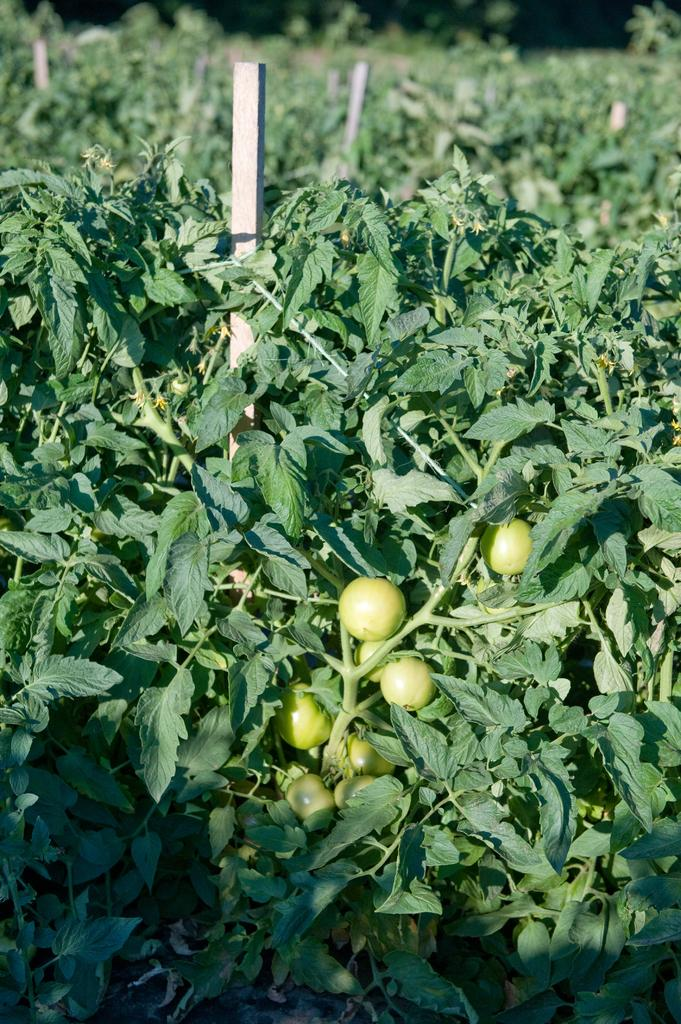What type of living organisms can be seen in the image? There are many plants in the image. What else can be seen in the image besides plants? There are fruits in the image. Can you describe any other objects in the image? There are unspecified objects in the image. What type of tramp can be seen in the image? There is no tramp present in the image. What substance is being used to grow the plants in the image? The provided facts do not mention any specific substances used for growing the plants, so we cannot determine that information from the image. 